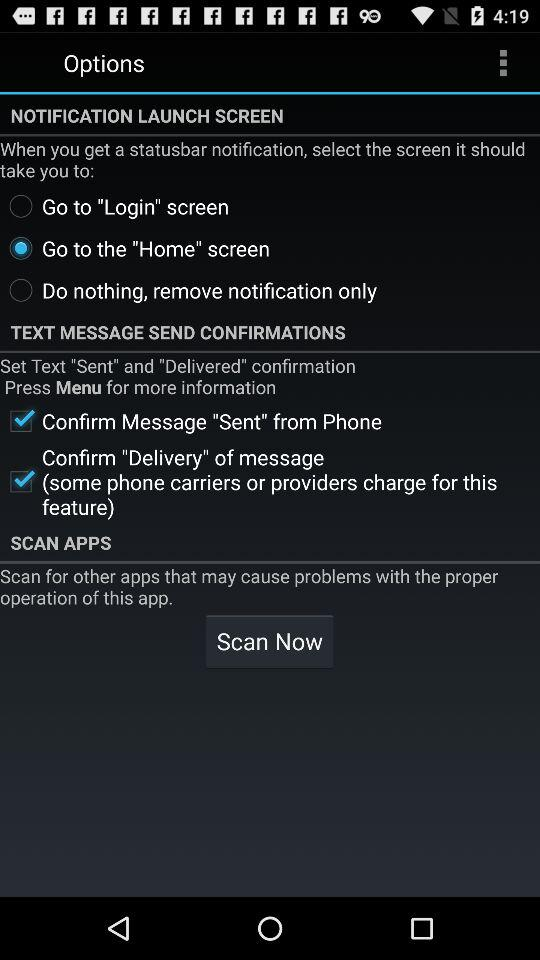What is the status of the "Confirm Message "Sent" from the phone"? The status is "on". 